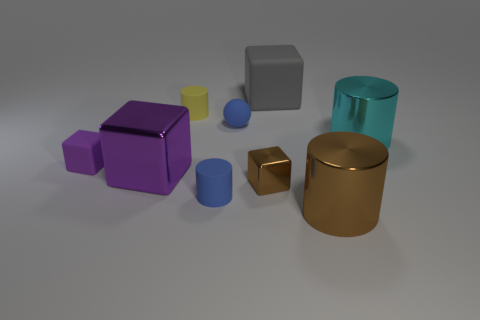Are there an equal number of big brown cylinders that are behind the small purple matte thing and big brown objects?
Your answer should be very brief. No. What number of things are purple rubber cylinders or tiny blocks that are on the right side of the small yellow matte cylinder?
Offer a very short reply. 1. Does the tiny sphere have the same color as the small matte block?
Your answer should be very brief. No. Are there any tiny cylinders made of the same material as the big gray block?
Your answer should be very brief. Yes. What color is the other tiny rubber object that is the same shape as the small yellow object?
Ensure brevity in your answer.  Blue. Does the tiny ball have the same material as the big block that is in front of the small yellow object?
Make the answer very short. No. There is a blue thing behind the large thing that is to the right of the big brown metal cylinder; what is its shape?
Make the answer very short. Sphere. Is the size of the matte block that is on the left side of the gray matte cube the same as the tiny yellow thing?
Your response must be concise. Yes. How many other things are the same shape as the tiny purple matte object?
Your response must be concise. 3. There is a rubber cube left of the large purple block; does it have the same color as the small metallic block?
Give a very brief answer. No. 